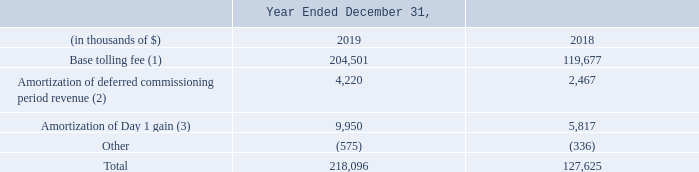B) liquefaction services revenue:
the hilli is moored in close proximity to the customer’s gasfields, providing liquefaction service capacity over the term of the lta. liquefaction services revenue recognized comprises the following amounts:
(1) the lta bills at a base rate in periods when the oil price is $60 or less per barrel (included in "liquefaction services revenue" in the consolidated statements of income), and at an increased rate when the oil price is greater than $60 per barrel (recognized as a derivative and included in "realized and unrealized gain on oil derivative instrument" in the consolidated statements of income, excluded from revenue and from the transaction price).
(2) customer billing during the commissioning period, prior to vessel acceptance and commencement of the contract term, of $33.8 million is considered an upfront payment for services. these amounts billed were deferred (included in "other current liabilities" and "other non-current liabilities" in the consolidated balance sheets) and recognized as part of "liquefaction services revenue" in the consolidated statements of income evenly over the contract term.
(3) the day 1 gain was established when the oil derivative instrument was initially recognized in december 2017 for $79.6 million (recognized in "other current liabilities" and "other non-current liabilities" in the consolidated balance sheets). this amount is amortized and recognized as part of "liquefaction services revenue" in the consolidated statements of income evenly over the contract term.
we expect to recognize liquefaction services revenue related to the partially unsatisfied performance obligation at the reporting date evenly over the remaining contract term of less than eight years, including the components of transaction price described above.
how much was the customer billing during the commissioning period? $33.8 million. In which years as the liquefaction services revenue recorded for? 2019, 2018. What was the amortization of deferred commissioning period revenue in 2018?
Answer scale should be: thousand. 2,467. In which year was the amortization of Day 1 gain lower? 5,817 < 9,950
Answer: 2018. What was the change in base tolling fee between 2018 and 2019?
Answer scale should be: thousand. 204,501 - 119,677 
Answer: 84824. What was the percentage change in the total liquefaction services revenue between 2018 and 2019?
Answer scale should be: percent. (218,096 - 127,625)/127,625 
Answer: 70.89. 